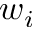<formula> <loc_0><loc_0><loc_500><loc_500>w _ { i }</formula> 